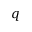Convert formula to latex. <formula><loc_0><loc_0><loc_500><loc_500>q</formula> 